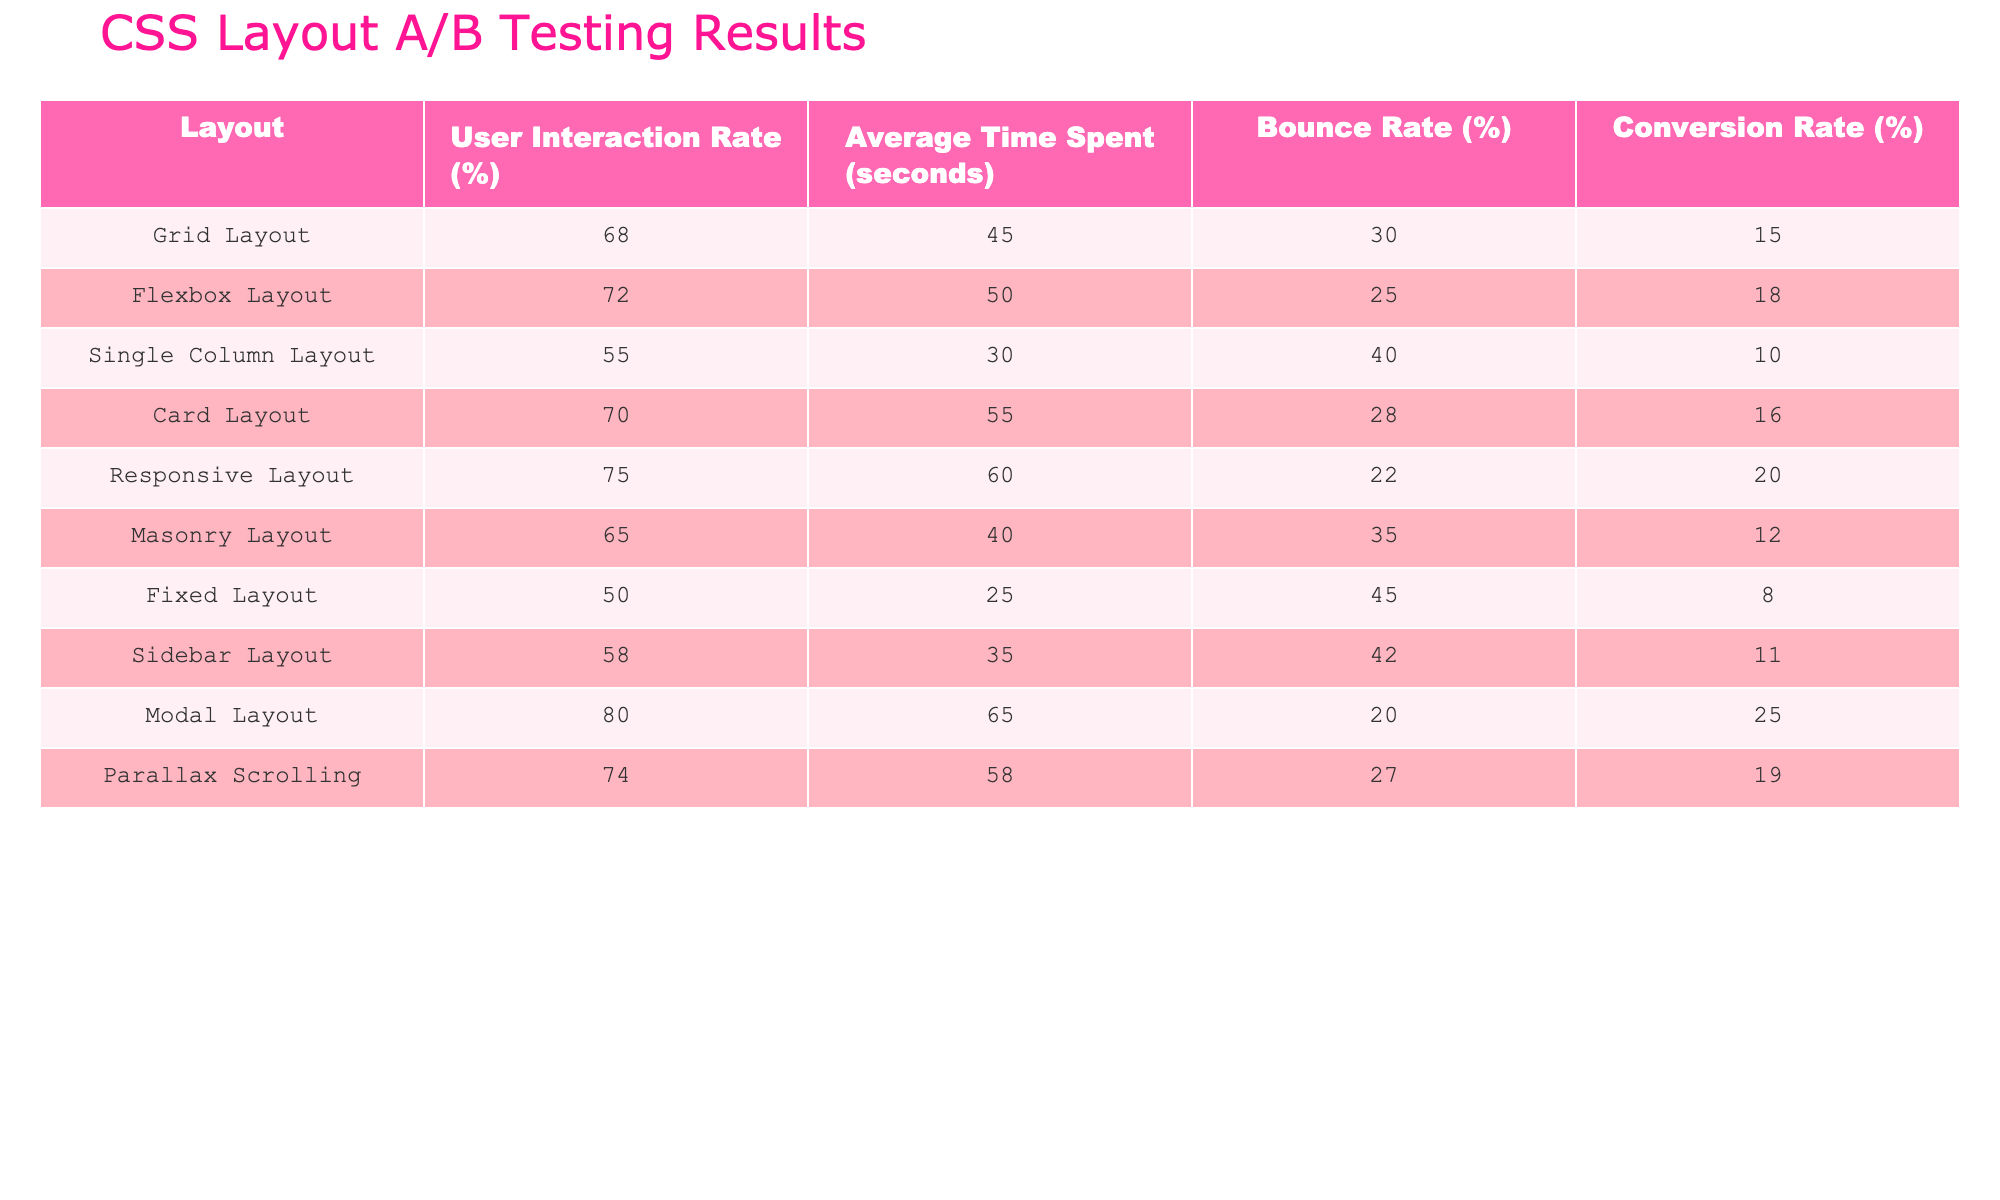What is the User Interaction Rate for the Modal Layout? The User Interaction Rate for the Modal Layout is found in the table under the column labeled "User Interaction Rate (%)", corresponding to the "Modal Layout" row, which states 80.
Answer: 80 Which layout has the highest Bounce Rate? To find the layout with the highest Bounce Rate, we compare the values in the "Bounce Rate (%)" column. The Fixed Layout has the highest value at 45%.
Answer: Fixed Layout What is the average User Interaction Rate for all layouts? To calculate the average User Interaction Rate, we sum the percentages (68 + 72 + 55 + 70 + 75 + 65 + 50 + 58 + 80 + 74 =  65.8) and then divide by the number of layouts (10). The average is therefore 66.8%.
Answer: 66.8 Is the Conversion Rate for the Responsive Layout higher than that of the Grid Layout? The Conversion Rate for the Responsive Layout is 20% and for the Grid Layout, it is 15%. Since 20% is greater than 15%, the statement is true.
Answer: Yes Which layout has the lowest Average Time Spent? The layout with the lowest Average Time Spent can be identified by looking at the "Average Time Spent (seconds)" column. The Fixed Layout has the lowest value at 25 seconds.
Answer: Fixed Layout What is the difference in Bounce Rate between the Modal Layout and the Single Column Layout? To find the difference in Bounce Rate, subtract the Bounce Rate of the Single Column Layout (40%) from that of the Modal Layout (20%). The calculation results in a difference of 20%.
Answer: 20% Is there a layout with a User Interaction Rate of over 75%? By examining the "User Interaction Rate (%)" column, two layouts exceed 75%: the Responsive Layout (75%) and the Modal Layout (80%). Therefore, it is true that there is at least one.
Answer: Yes How does the Conversion Rate of the Flexbox Layout compare to that of the Card Layout? The Conversion Rate for the Flexbox Layout is 18% and for the Card Layout, it is 16%. Since 18% is higher than 16%, Flexbox Layout has a better Conversion Rate than Card Layout.
Answer: Flexbox Layout What is the average Bounce Rate for the Card Layout and Parallax Scrolling Layout? To find the average Bounce Rate, first sum the Bounce Rates for both layouts (28 + 27 = 55) and divide by 2 (55 / 2 = 27.5). Therefore, the average Bounce Rate for these layouts is 27.5%.
Answer: 27.5 